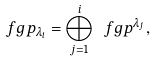<formula> <loc_0><loc_0><loc_500><loc_500>\ f g p _ { \lambda _ { i } } = \bigoplus _ { j = 1 } ^ { i } \ f g p ^ { \lambda _ { j } } ,</formula> 